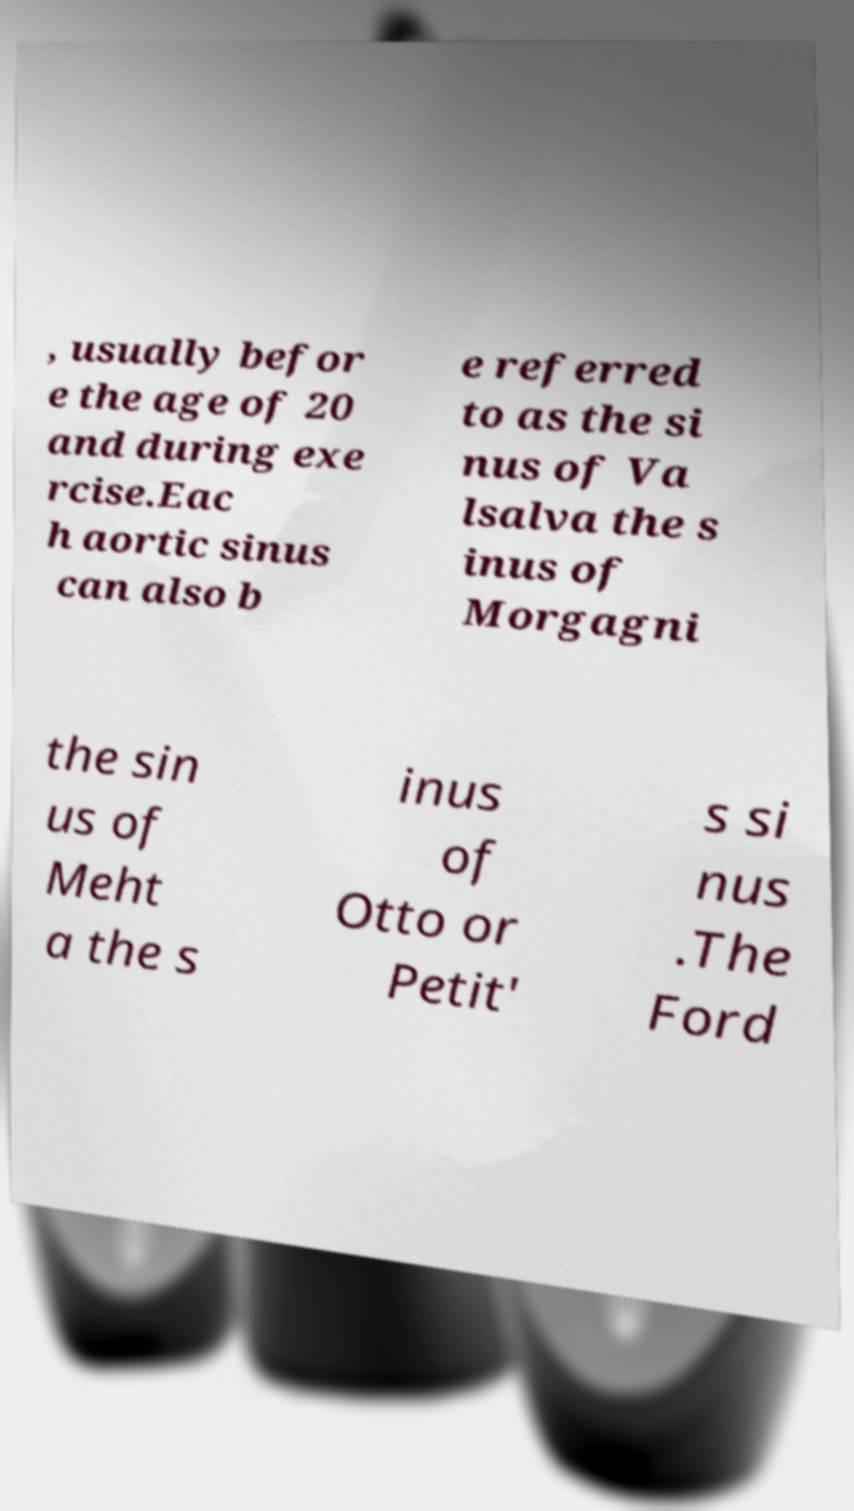There's text embedded in this image that I need extracted. Can you transcribe it verbatim? , usually befor e the age of 20 and during exe rcise.Eac h aortic sinus can also b e referred to as the si nus of Va lsalva the s inus of Morgagni the sin us of Meht a the s inus of Otto or Petit' s si nus .The Ford 